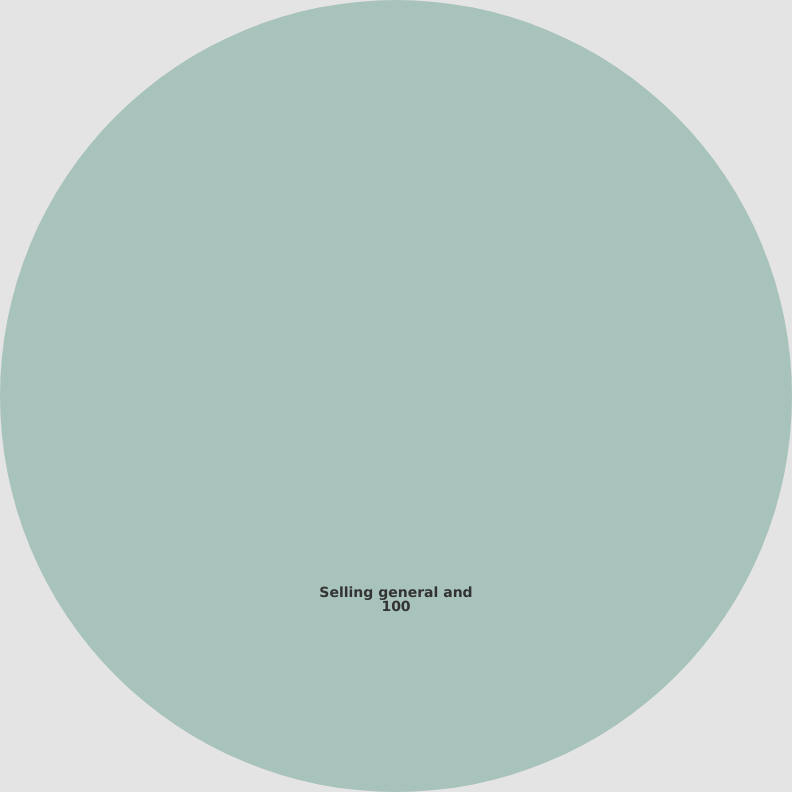Convert chart. <chart><loc_0><loc_0><loc_500><loc_500><pie_chart><fcel>Selling general and<nl><fcel>100.0%<nl></chart> 